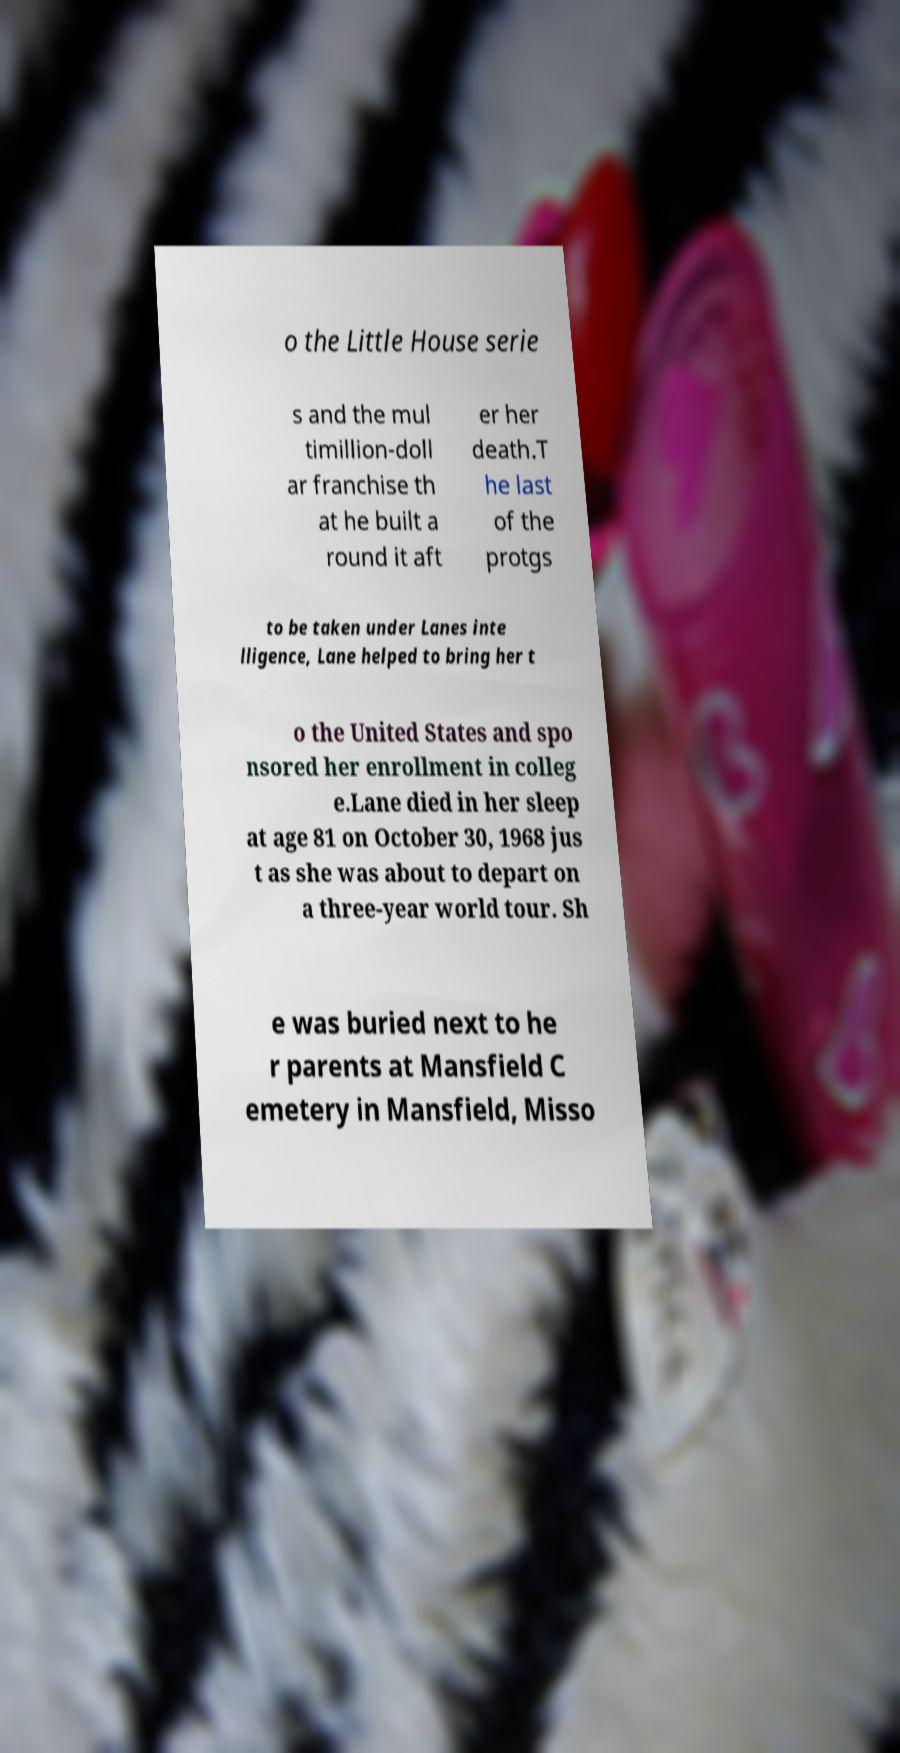What messages or text are displayed in this image? I need them in a readable, typed format. o the Little House serie s and the mul timillion-doll ar franchise th at he built a round it aft er her death.T he last of the protgs to be taken under Lanes inte lligence, Lane helped to bring her t o the United States and spo nsored her enrollment in colleg e.Lane died in her sleep at age 81 on October 30, 1968 jus t as she was about to depart on a three-year world tour. Sh e was buried next to he r parents at Mansfield C emetery in Mansfield, Misso 